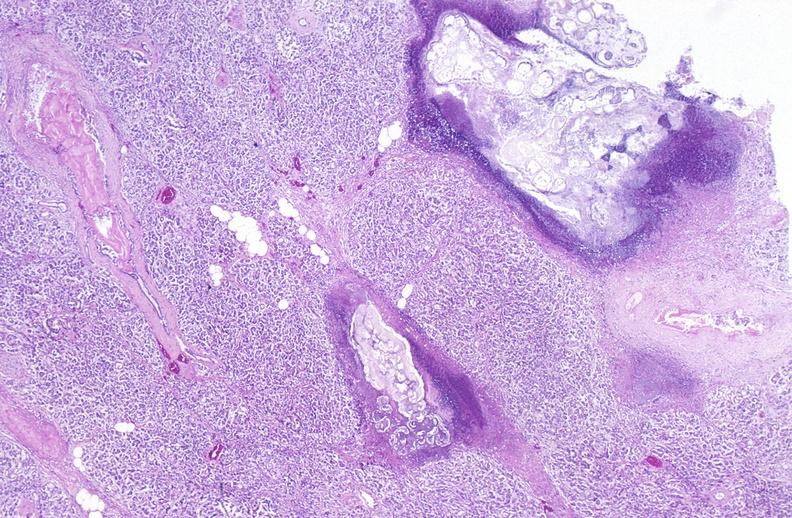does this image show pancreatic fat necrosis?
Answer the question using a single word or phrase. Yes 